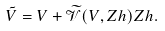<formula> <loc_0><loc_0><loc_500><loc_500>\tilde { V } = V + \widetilde { \mathcal { V } } ( V , Z h ) Z h .</formula> 